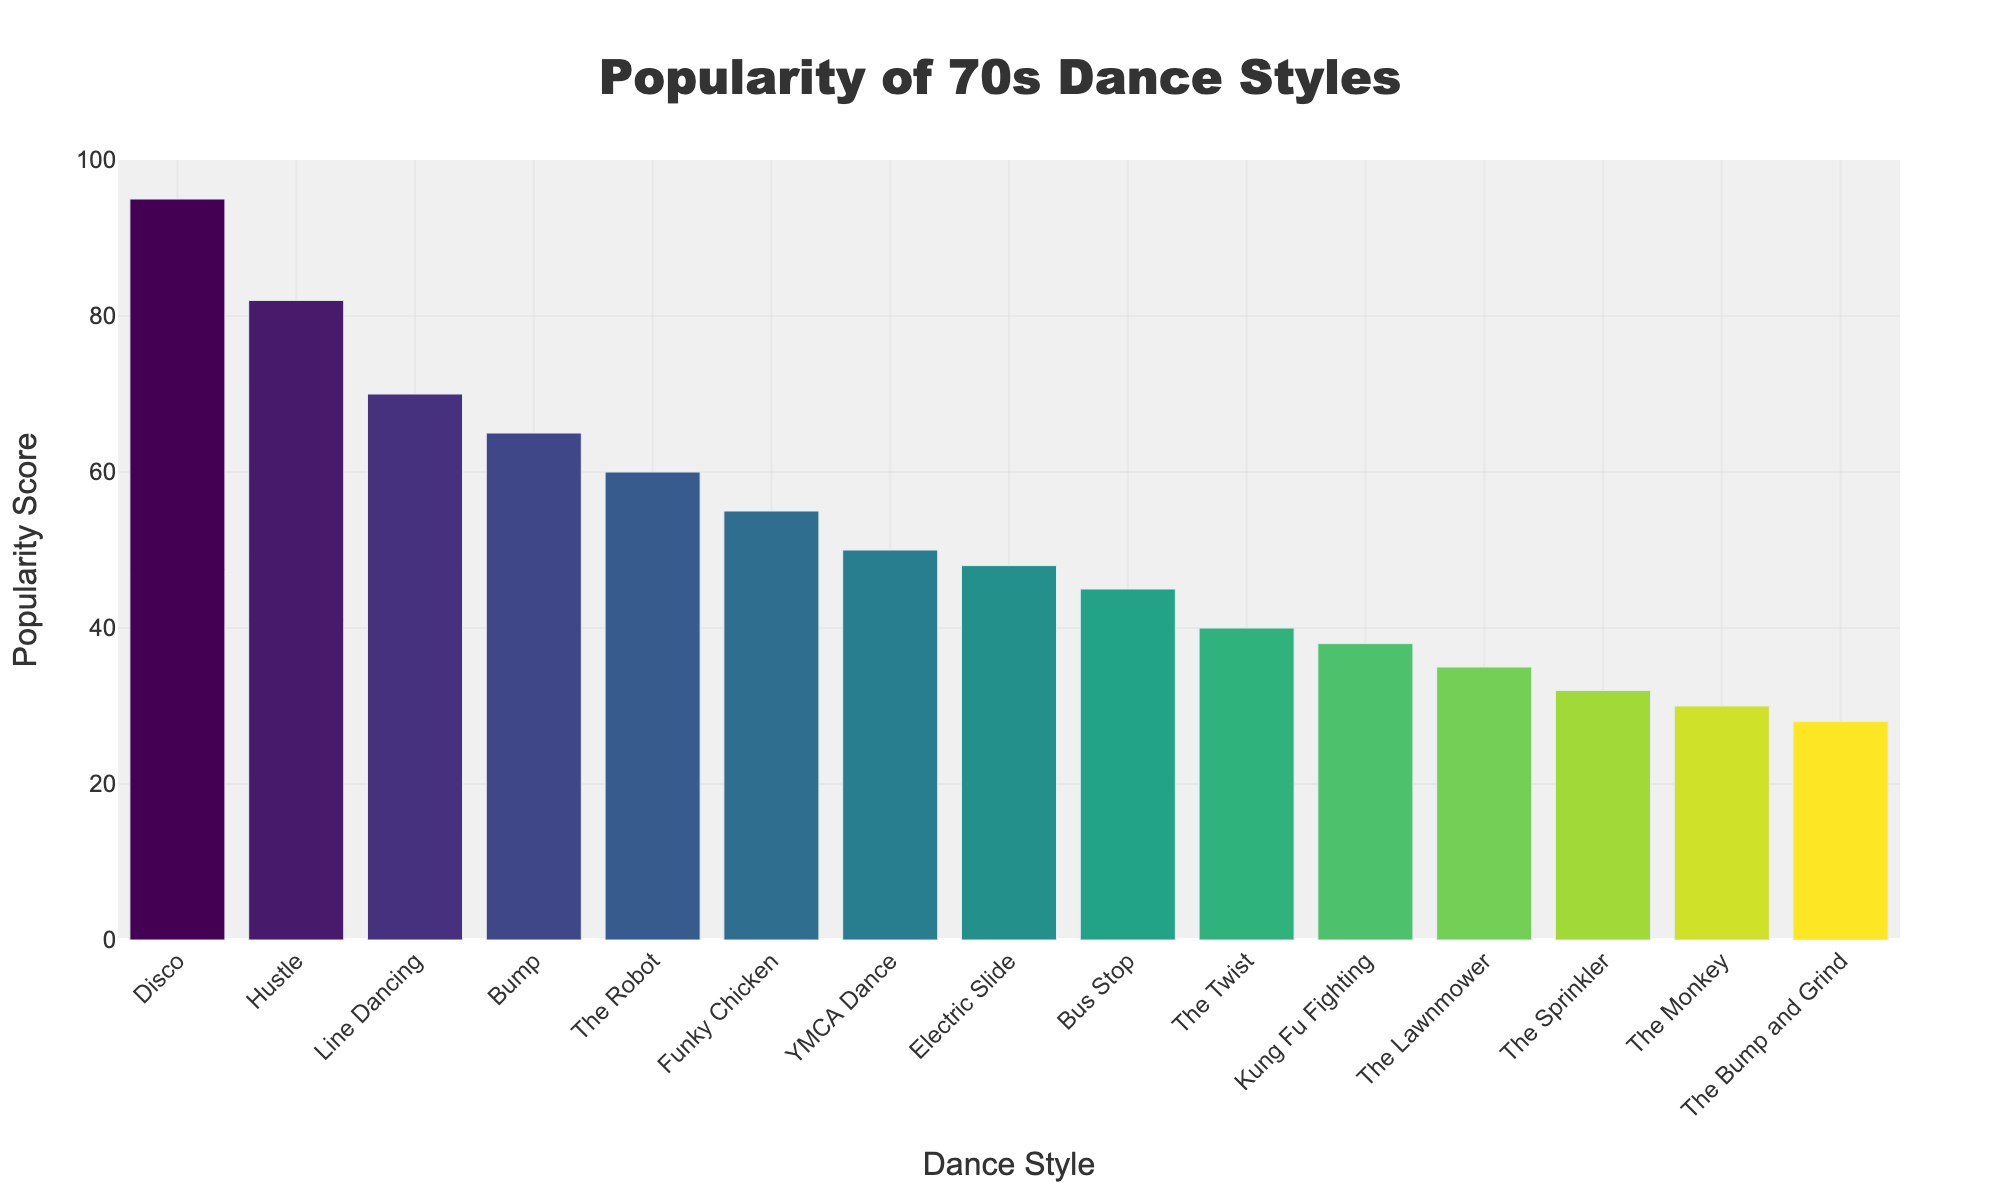Which dance style has the highest popularity score? The bar for Disco reaches the highest point on the y-axis, indicating it has the highest popularity score among the dance styles.
Answer: Disco What is the difference in popularity score between the Hustle and the Bump? The popularity score for the Hustle is 82, and for the Bump, it is 65. The difference is 82 - 65.
Answer: 17 Which dance style is more popular, the Electric Slide or the Bus Stop? Comparing the heights of the bars, the Electric Slide has a popularity score of 48, while the Bus Stop has a score of 45. The Electric Slide is more popular.
Answer: Electric Slide What is the combined popularity score of Line Dancing and YMCA Dance? Line Dancing has a popularity score of 70, and YMCA Dance has a score of 50. Combined, the score is 70 + 50.
Answer: 120 How many dance styles have a popularity score above 50? Counting the bars that reach above the 50 mark on the y-axis, there are 4: Disco, Hustle, Line Dancing, and the Bump.
Answer: 4 Which dance style has the lowest popularity score? The bar for The Bump and Grind reaches the lowest point on the y-axis, indicating it has the lowest popularity score among the dance styles.
Answer: The Bump and Grind Is The Robot more popular than the Bump? The Robot has a popularity score of 60, while the Bump has a score of 65. The Robot is less popular.
Answer: No What is the average popularity score of the top 3 dance styles? The top three dance styles by popularity are Disco (95), Hustle (82), and Line Dancing (70). Their average score is (95 + 82 + 70) / 3.
Answer: 82.33 How much more popular is the Funky Chicken compared to the Sprinkler? The Funky Chicken has a popularity score of 55, and the Sprinkler has a score of 32. The difference is 55 - 32.
Answer: 23 